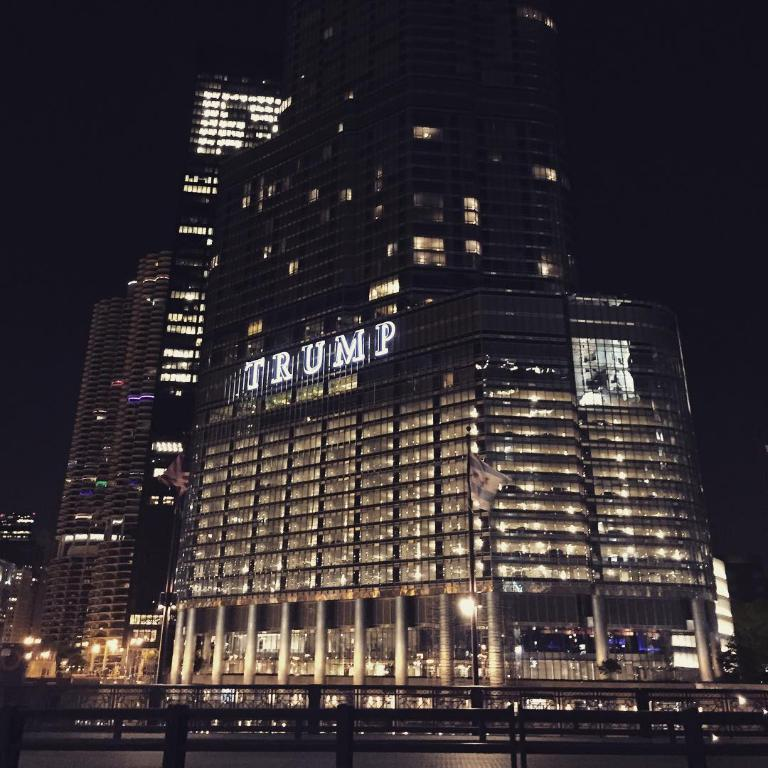What type of structure is visible in the image? There is a building in the image. What features can be observed on the building? The building has windows, lights, and pillars. What is attached to a pole in the image? There is a flag on a pole in the image. What type of barrier is present in the image? There is a fence in the image. How many clocks are visible on the building in the image? There is no mention of clocks in the image; the building has windows, lights, and pillars, but no clocks are described. 